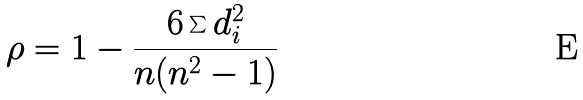Convert formula to latex. <formula><loc_0><loc_0><loc_500><loc_500>\rho = 1 - \frac { 6 \sum d _ { i } ^ { 2 } } { n ( n ^ { 2 } - 1 ) }</formula> 